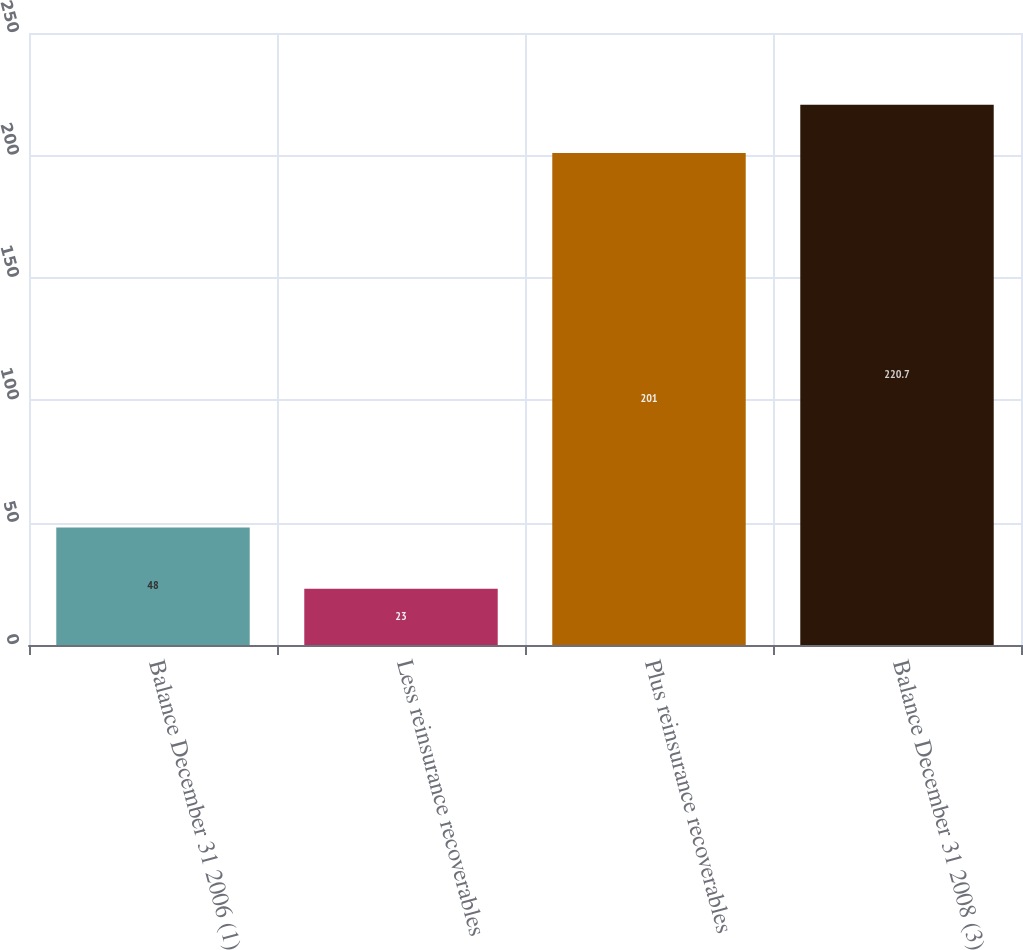Convert chart. <chart><loc_0><loc_0><loc_500><loc_500><bar_chart><fcel>Balance December 31 2006 (1)<fcel>Less reinsurance recoverables<fcel>Plus reinsurance recoverables<fcel>Balance December 31 2008 (3)<nl><fcel>48<fcel>23<fcel>201<fcel>220.7<nl></chart> 